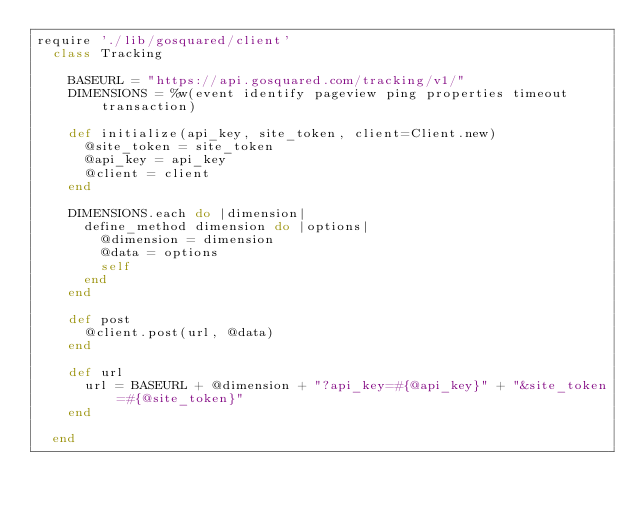<code> <loc_0><loc_0><loc_500><loc_500><_Ruby_>require './lib/gosquared/client'
	class Tracking

		BASEURL = "https://api.gosquared.com/tracking/v1/"
		DIMENSIONS = %w(event identify pageview ping properties timeout transaction)	

		def initialize(api_key, site_token, client=Client.new)
			@site_token = site_token
			@api_key = api_key
			@client = client
		end

		DIMENSIONS.each do |dimension|
			define_method dimension do |options|
				@dimension = dimension 
				@data = options
				self
			end
		end

		def post
			@client.post(url, @data)
		end

		def url
			url = BASEURL + @dimension + "?api_key=#{@api_key}" + "&site_token=#{@site_token}" 
		end

	end</code> 